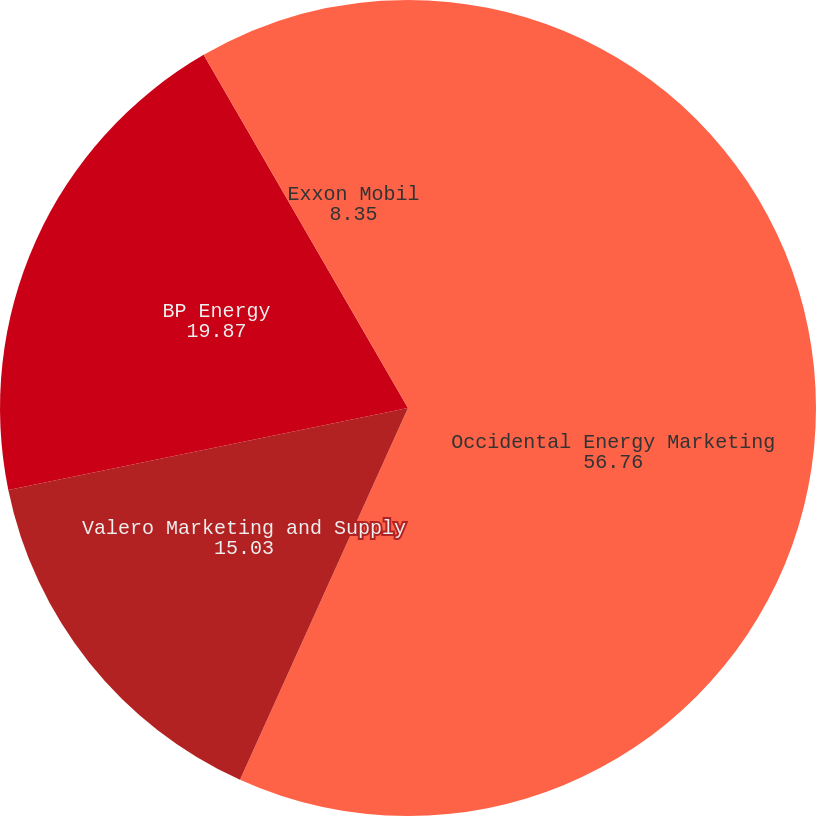Convert chart. <chart><loc_0><loc_0><loc_500><loc_500><pie_chart><fcel>Occidental Energy Marketing<fcel>Valero Marketing and Supply<fcel>BP Energy<fcel>Exxon Mobil<nl><fcel>56.76%<fcel>15.03%<fcel>19.87%<fcel>8.35%<nl></chart> 